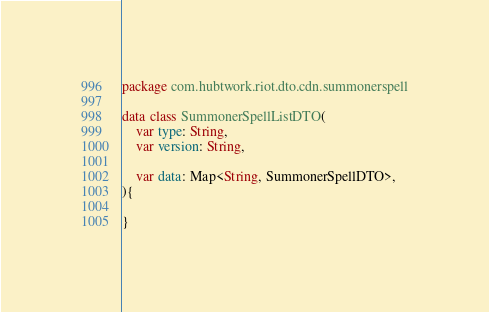Convert code to text. <code><loc_0><loc_0><loc_500><loc_500><_Kotlin_>package com.hubtwork.riot.dto.cdn.summonerspell

data class SummonerSpellListDTO(
    var type: String,
    var version: String,

    var data: Map<String, SummonerSpellDTO>,
){

}
</code> 